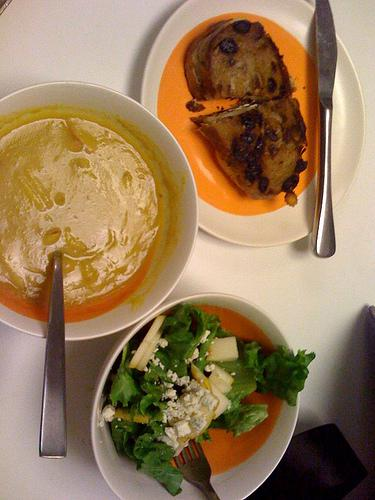Question: what color is the bowl?
Choices:
A. White.
B. Red.
C. Yellow.
D. Orange.
Answer with the letter. Answer: A Question: who is in the photo?
Choices:
A. One person.
B. Nobody.
C. Two people.
D. Three people.
Answer with the letter. Answer: B Question: how many utensils are there?
Choices:
A. Two.
B. Four.
C. Three.
D. Six.
Answer with the letter. Answer: C Question: when was the photo taken?
Choices:
A. Midnight.
B. Daytime.
C. Dusk.
D. Late night.
Answer with the letter. Answer: B 